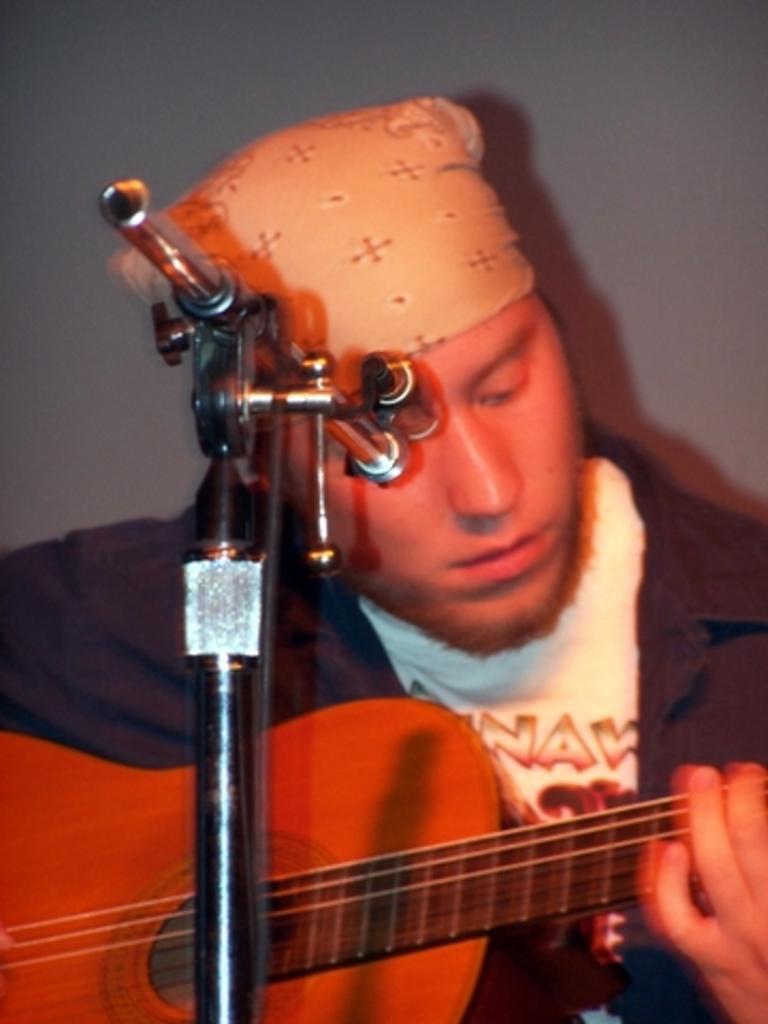Describe this image in one or two sentences. In this image i can see a man holding a guitar,in front of a man there is a stand. 